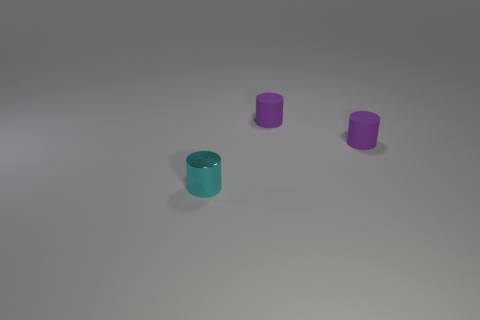What material do the objects look like they're made of? The objects have a glossy surface, suggesting they could be made of a reflective material like metal, glass, or polished plastic. Is there anything else in the image aside from the objects? Aside from the objects, the image also features a smooth surface below them which could be a table or a floor, and there's a light source creating reflections and shadows. 